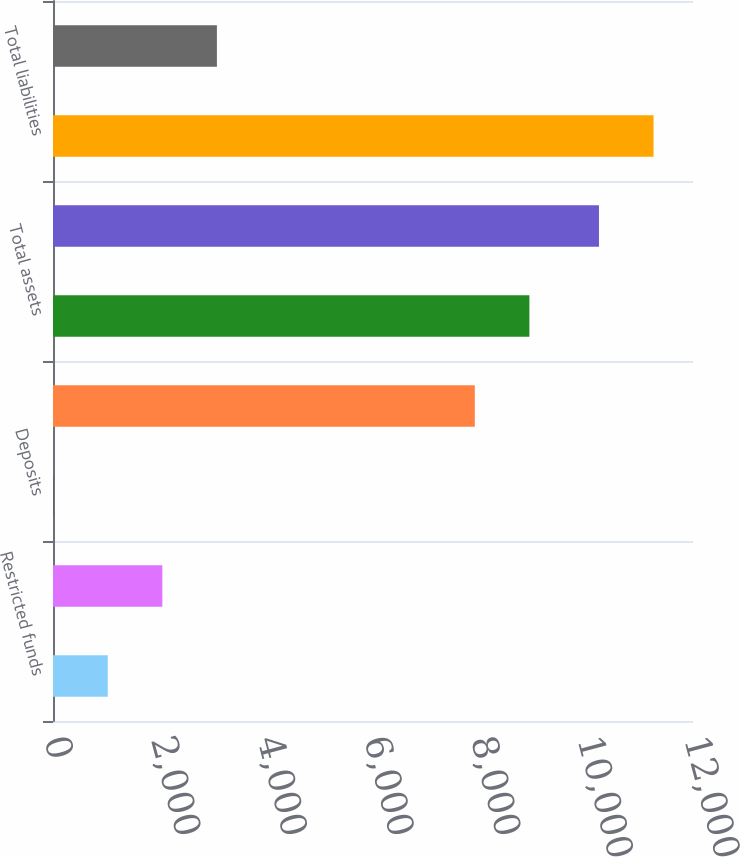Convert chart. <chart><loc_0><loc_0><loc_500><loc_500><bar_chart><fcel>Restricted funds<fcel>Rabbi trust investments<fcel>Deposits<fcel>Mark-to-market derivative<fcel>Total assets<fcel>Deferred compensation<fcel>Total liabilities<fcel>Total net assets (liabilities)<nl><fcel>1026.46<fcel>2049.85<fcel>3.07<fcel>7909<fcel>8932.39<fcel>10237<fcel>11260.4<fcel>3073.24<nl></chart> 